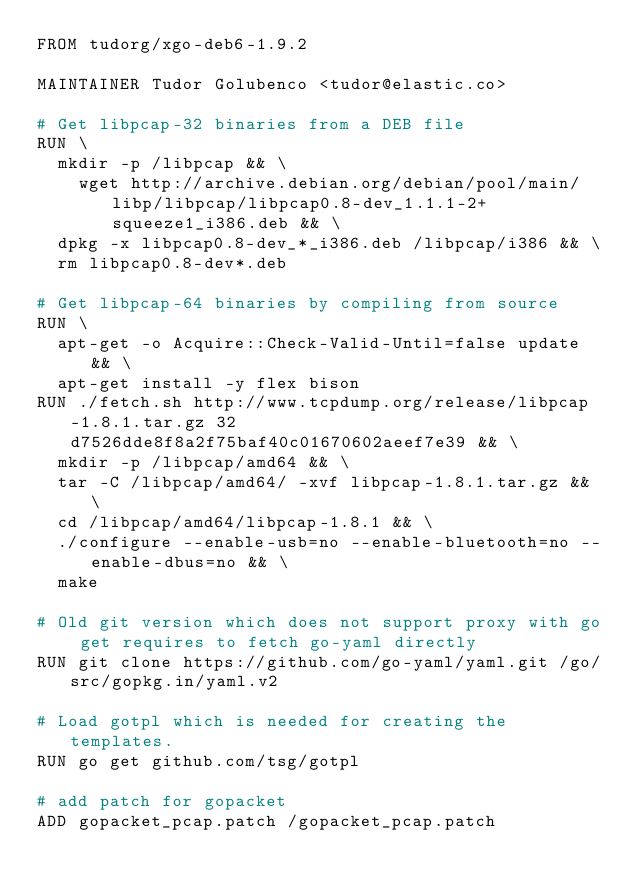Convert code to text. <code><loc_0><loc_0><loc_500><loc_500><_Dockerfile_>FROM tudorg/xgo-deb6-1.9.2

MAINTAINER Tudor Golubenco <tudor@elastic.co>

# Get libpcap-32 binaries from a DEB file
RUN \
	mkdir -p /libpcap && \
    wget http://archive.debian.org/debian/pool/main/libp/libpcap/libpcap0.8-dev_1.1.1-2+squeeze1_i386.deb && \
	dpkg -x libpcap0.8-dev_*_i386.deb /libpcap/i386 && \
	rm libpcap0.8-dev*.deb

# Get libpcap-64 binaries by compiling from source
RUN \
	apt-get -o Acquire::Check-Valid-Until=false update && \
	apt-get install -y flex bison
RUN ./fetch.sh http://www.tcpdump.org/release/libpcap-1.8.1.tar.gz 32d7526dde8f8a2f75baf40c01670602aeef7e39 && \
  mkdir -p /libpcap/amd64 && \
  tar -C /libpcap/amd64/ -xvf libpcap-1.8.1.tar.gz && \
  cd /libpcap/amd64/libpcap-1.8.1 && \
  ./configure --enable-usb=no --enable-bluetooth=no --enable-dbus=no && \
  make

# Old git version which does not support proxy with go get requires to fetch go-yaml directly
RUN git clone https://github.com/go-yaml/yaml.git /go/src/gopkg.in/yaml.v2

# Load gotpl which is needed for creating the templates.
RUN go get github.com/tsg/gotpl

# add patch for gopacket
ADD gopacket_pcap.patch /gopacket_pcap.patch
</code> 